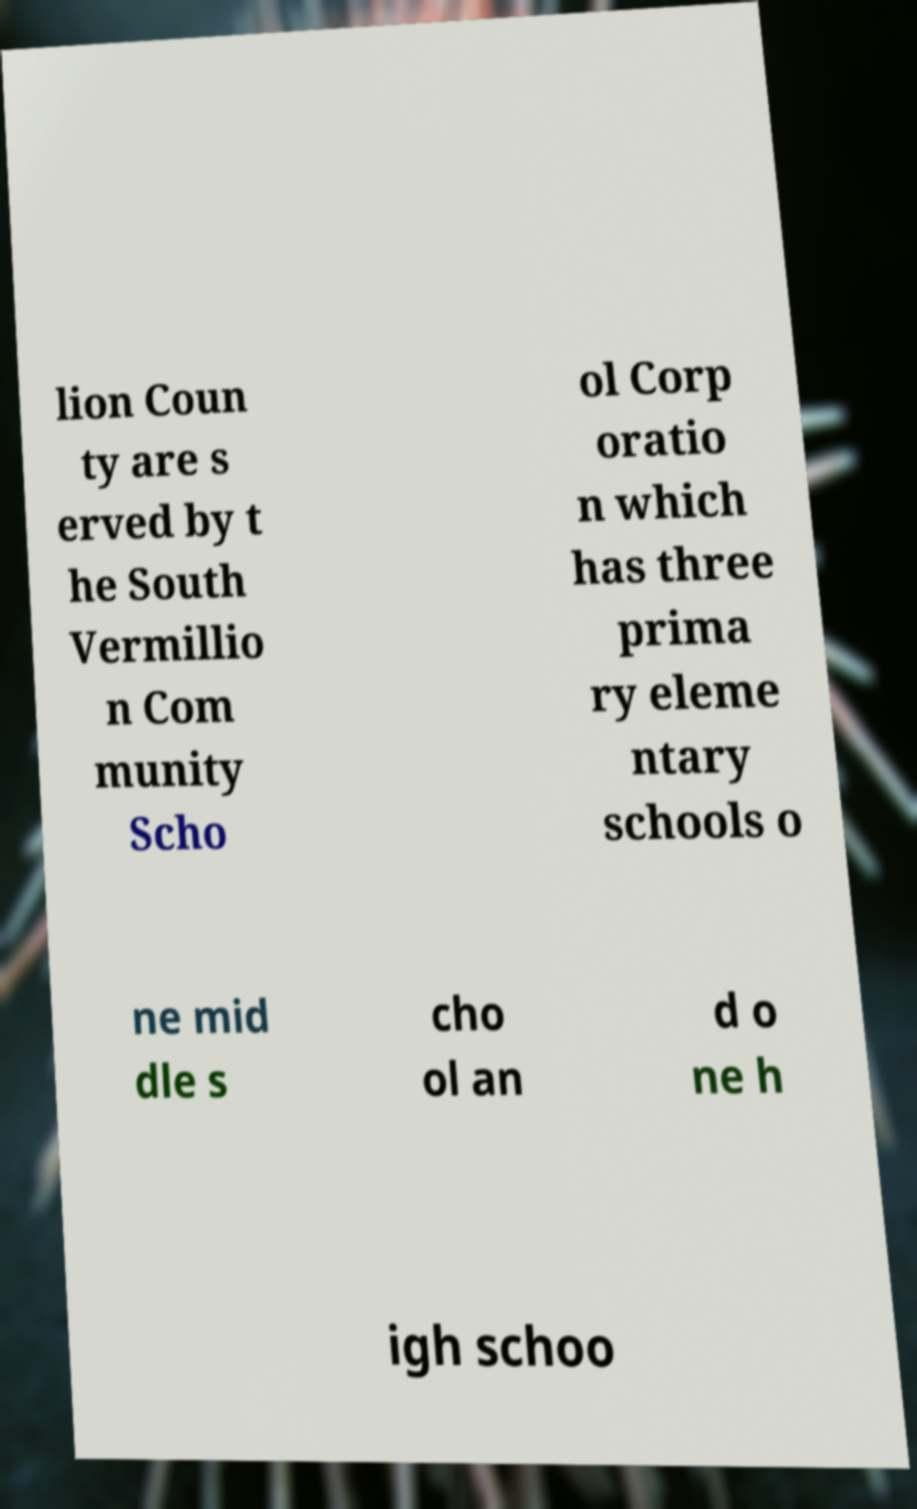Could you assist in decoding the text presented in this image and type it out clearly? lion Coun ty are s erved by t he South Vermillio n Com munity Scho ol Corp oratio n which has three prima ry eleme ntary schools o ne mid dle s cho ol an d o ne h igh schoo 